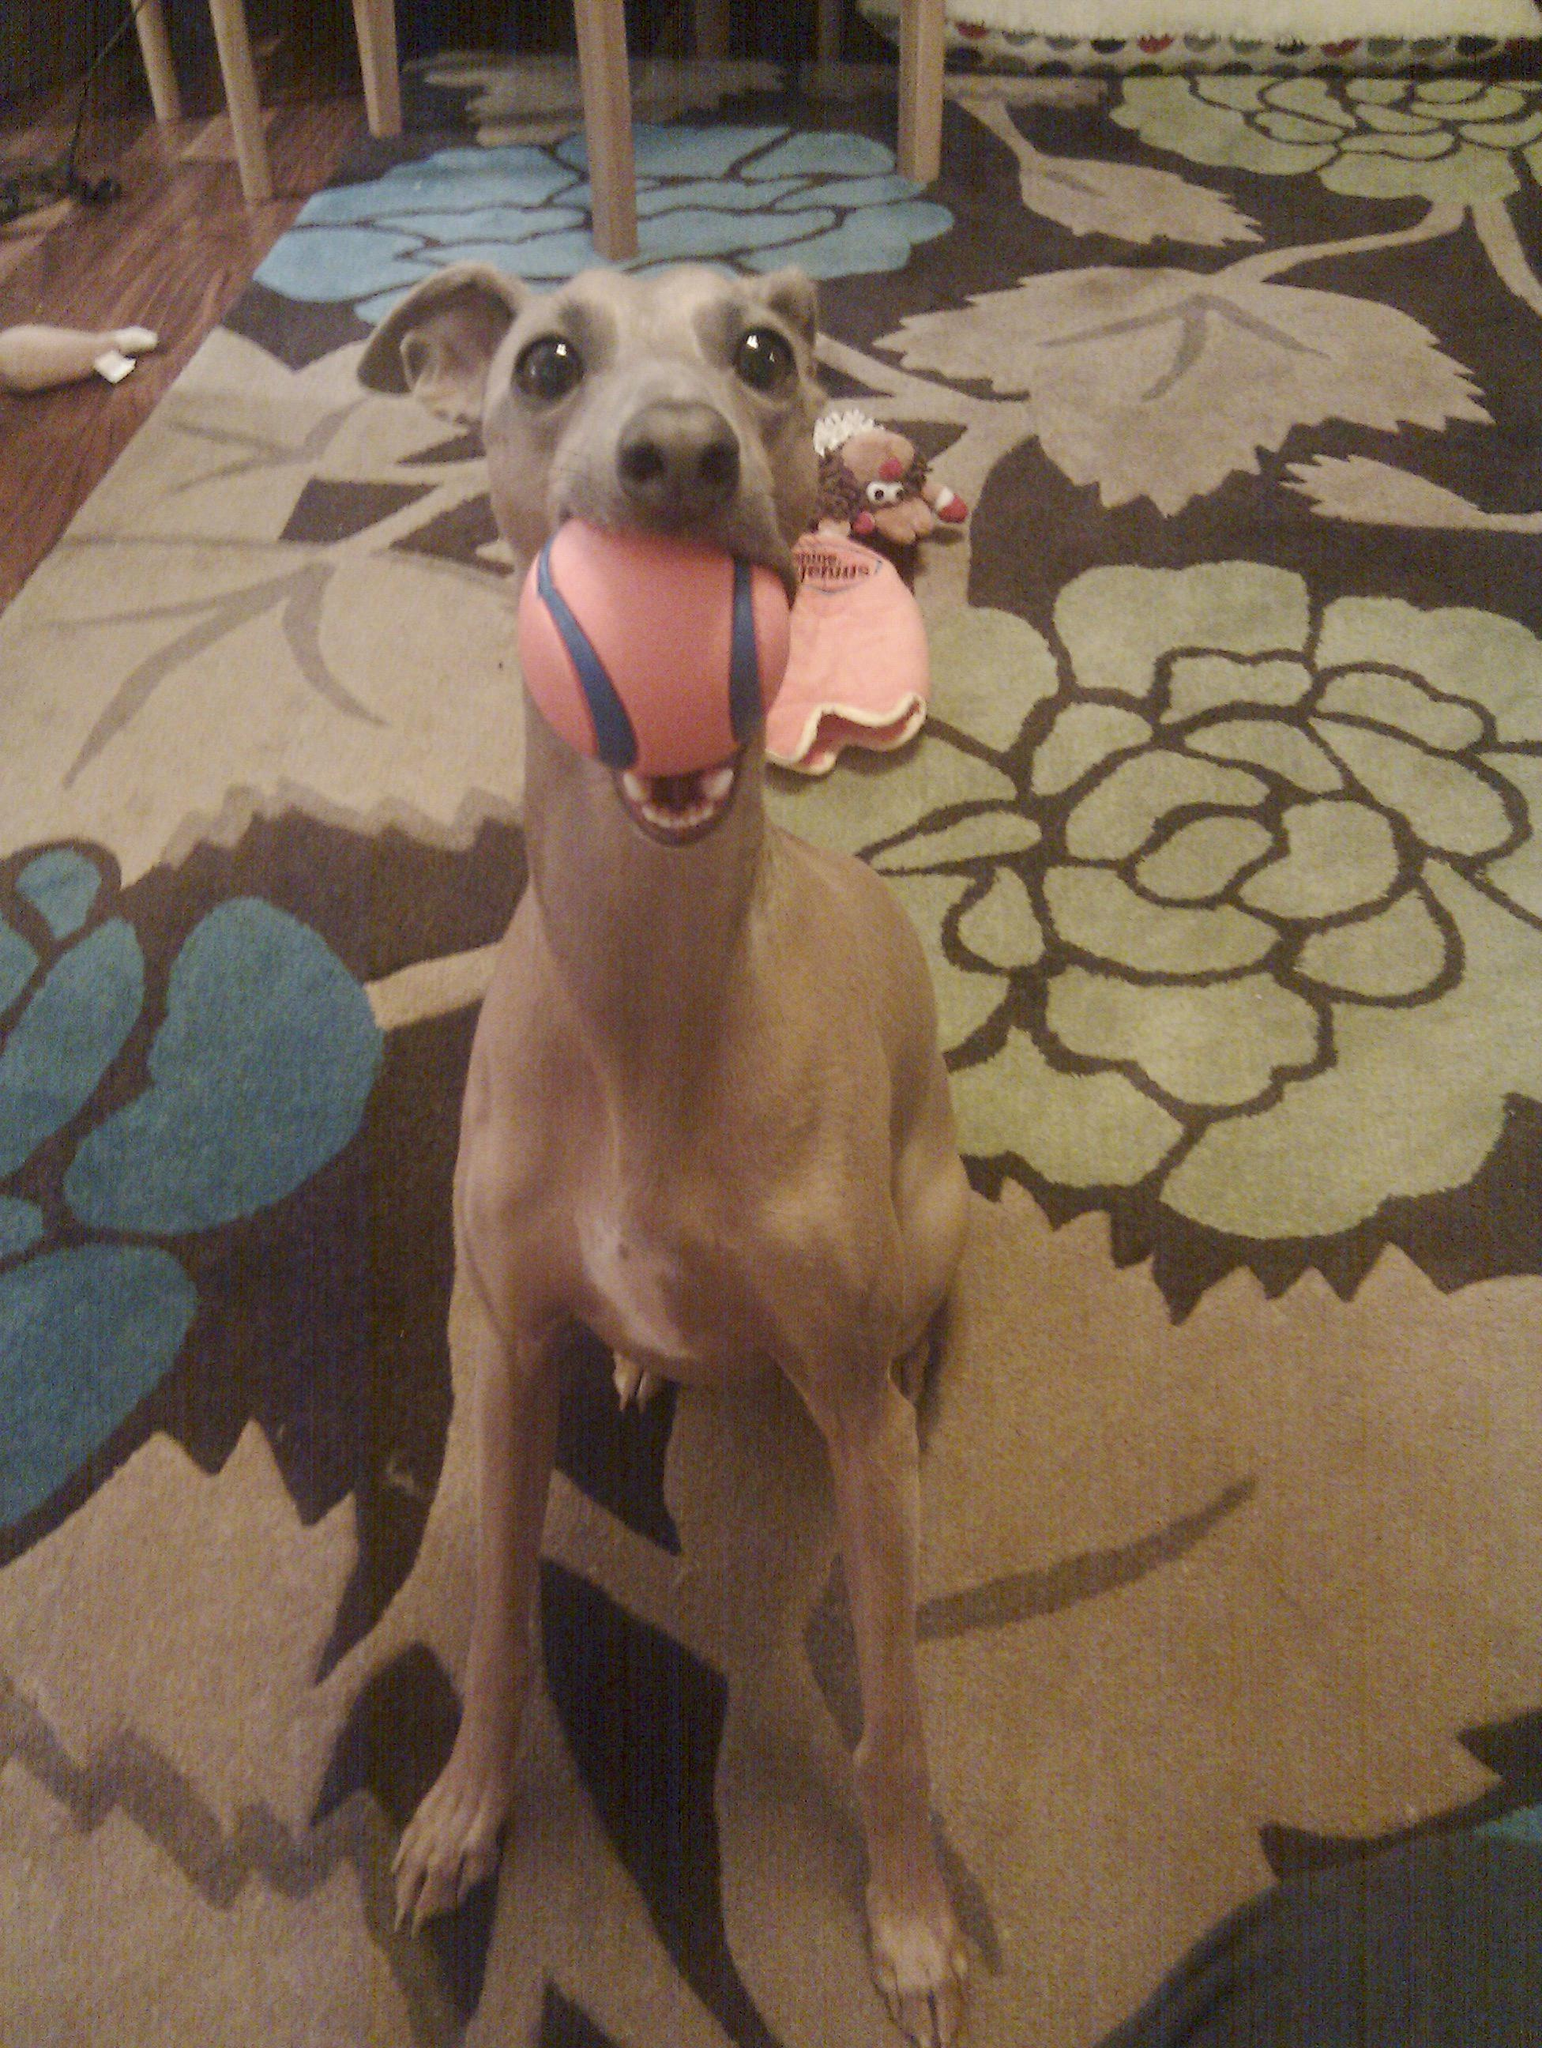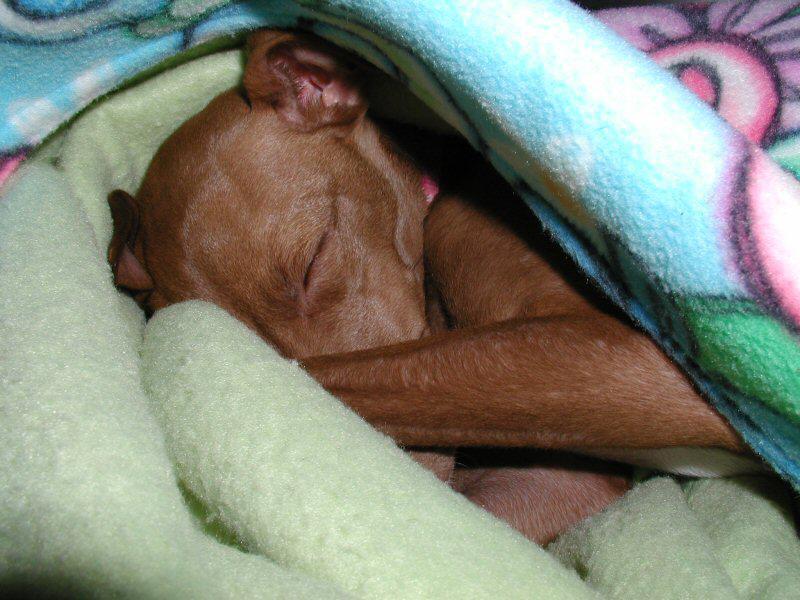The first image is the image on the left, the second image is the image on the right. Considering the images on both sides, is "There are two dogs and zero humans, and the dog on the right is laying on a blanket." valid? Answer yes or no. Yes. The first image is the image on the left, the second image is the image on the right. Evaluate the accuracy of this statement regarding the images: "An image contains one leftward-facing snoozing brown dog, snuggled with folds of blanket and no human present.". Is it true? Answer yes or no. Yes. 